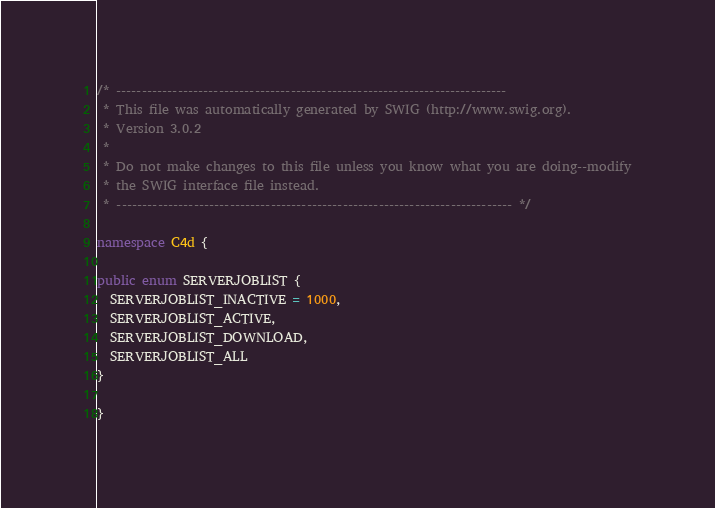Convert code to text. <code><loc_0><loc_0><loc_500><loc_500><_C#_>/* ----------------------------------------------------------------------------
 * This file was automatically generated by SWIG (http://www.swig.org).
 * Version 3.0.2
 *
 * Do not make changes to this file unless you know what you are doing--modify
 * the SWIG interface file instead.
 * ----------------------------------------------------------------------------- */

namespace C4d {

public enum SERVERJOBLIST {
  SERVERJOBLIST_INACTIVE = 1000,
  SERVERJOBLIST_ACTIVE,
  SERVERJOBLIST_DOWNLOAD,
  SERVERJOBLIST_ALL
}

}
</code> 